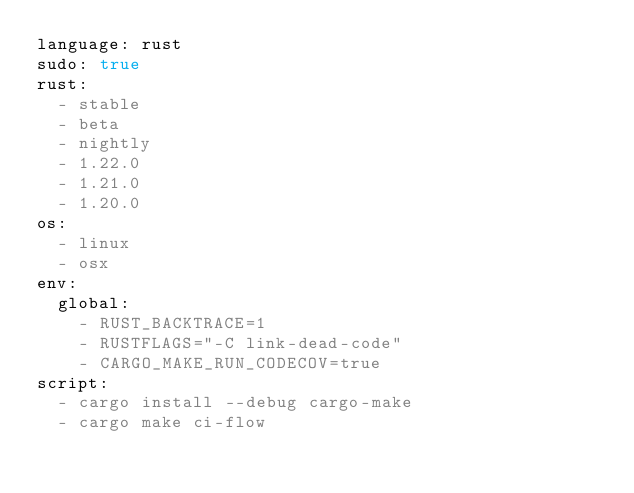<code> <loc_0><loc_0><loc_500><loc_500><_YAML_>language: rust
sudo: true
rust:
  - stable
  - beta
  - nightly
  - 1.22.0
  - 1.21.0
  - 1.20.0
os:
  - linux
  - osx
env:
  global:
    - RUST_BACKTRACE=1
    - RUSTFLAGS="-C link-dead-code"
    - CARGO_MAKE_RUN_CODECOV=true
script:
  - cargo install --debug cargo-make
  - cargo make ci-flow
</code> 